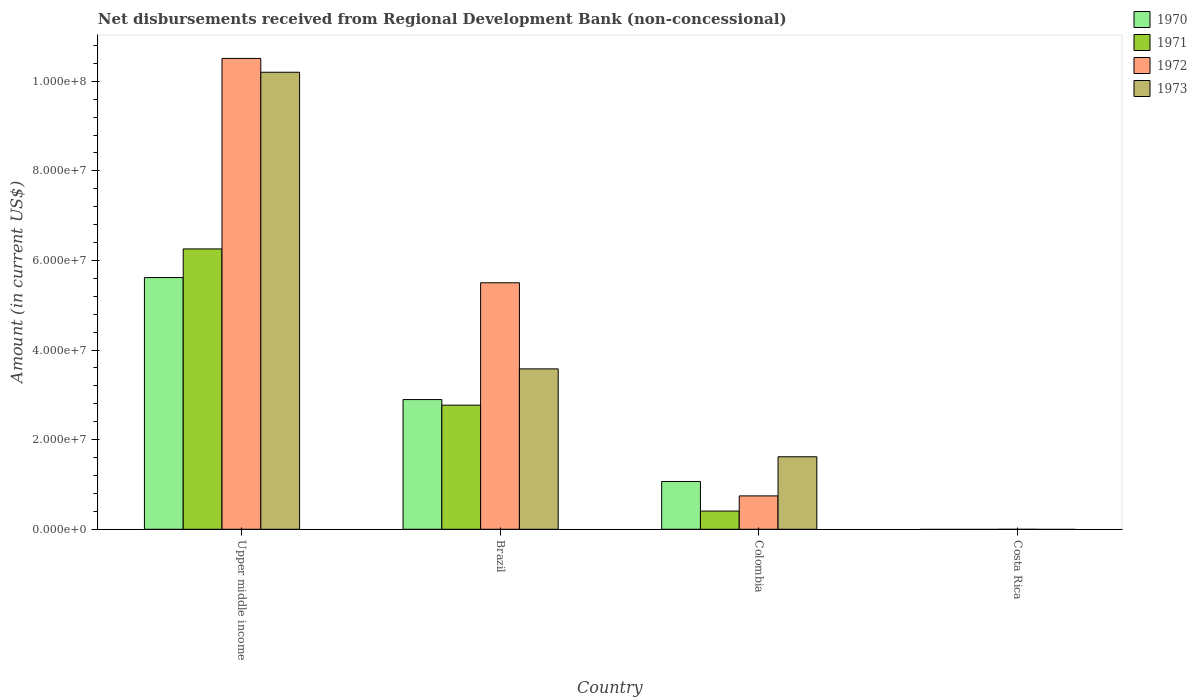Are the number of bars per tick equal to the number of legend labels?
Provide a short and direct response. No. What is the label of the 1st group of bars from the left?
Provide a short and direct response. Upper middle income. In how many cases, is the number of bars for a given country not equal to the number of legend labels?
Provide a succinct answer. 1. What is the amount of disbursements received from Regional Development Bank in 1970 in Colombia?
Offer a terse response. 1.07e+07. Across all countries, what is the maximum amount of disbursements received from Regional Development Bank in 1973?
Ensure brevity in your answer.  1.02e+08. In which country was the amount of disbursements received from Regional Development Bank in 1970 maximum?
Make the answer very short. Upper middle income. What is the total amount of disbursements received from Regional Development Bank in 1973 in the graph?
Your answer should be very brief. 1.54e+08. What is the difference between the amount of disbursements received from Regional Development Bank in 1973 in Brazil and that in Upper middle income?
Make the answer very short. -6.62e+07. What is the difference between the amount of disbursements received from Regional Development Bank in 1970 in Colombia and the amount of disbursements received from Regional Development Bank in 1972 in Costa Rica?
Keep it short and to the point. 1.07e+07. What is the average amount of disbursements received from Regional Development Bank in 1970 per country?
Provide a short and direct response. 2.40e+07. What is the difference between the amount of disbursements received from Regional Development Bank of/in 1972 and amount of disbursements received from Regional Development Bank of/in 1971 in Colombia?
Offer a terse response. 3.39e+06. What is the ratio of the amount of disbursements received from Regional Development Bank in 1971 in Brazil to that in Upper middle income?
Ensure brevity in your answer.  0.44. Is the amount of disbursements received from Regional Development Bank in 1971 in Brazil less than that in Colombia?
Your response must be concise. No. What is the difference between the highest and the second highest amount of disbursements received from Regional Development Bank in 1972?
Make the answer very short. 9.76e+07. What is the difference between the highest and the lowest amount of disbursements received from Regional Development Bank in 1970?
Your answer should be very brief. 5.62e+07. In how many countries, is the amount of disbursements received from Regional Development Bank in 1973 greater than the average amount of disbursements received from Regional Development Bank in 1973 taken over all countries?
Provide a short and direct response. 1. Is the sum of the amount of disbursements received from Regional Development Bank in 1972 in Brazil and Upper middle income greater than the maximum amount of disbursements received from Regional Development Bank in 1971 across all countries?
Your answer should be very brief. Yes. Is it the case that in every country, the sum of the amount of disbursements received from Regional Development Bank in 1972 and amount of disbursements received from Regional Development Bank in 1971 is greater than the sum of amount of disbursements received from Regional Development Bank in 1970 and amount of disbursements received from Regional Development Bank in 1973?
Ensure brevity in your answer.  No. How many countries are there in the graph?
Make the answer very short. 4. What is the difference between two consecutive major ticks on the Y-axis?
Keep it short and to the point. 2.00e+07. Does the graph contain any zero values?
Ensure brevity in your answer.  Yes. Does the graph contain grids?
Give a very brief answer. No. Where does the legend appear in the graph?
Offer a terse response. Top right. What is the title of the graph?
Ensure brevity in your answer.  Net disbursements received from Regional Development Bank (non-concessional). Does "2009" appear as one of the legend labels in the graph?
Your answer should be very brief. No. What is the label or title of the Y-axis?
Provide a succinct answer. Amount (in current US$). What is the Amount (in current US$) in 1970 in Upper middle income?
Provide a short and direct response. 5.62e+07. What is the Amount (in current US$) in 1971 in Upper middle income?
Your answer should be very brief. 6.26e+07. What is the Amount (in current US$) in 1972 in Upper middle income?
Ensure brevity in your answer.  1.05e+08. What is the Amount (in current US$) in 1973 in Upper middle income?
Your answer should be compact. 1.02e+08. What is the Amount (in current US$) of 1970 in Brazil?
Make the answer very short. 2.90e+07. What is the Amount (in current US$) in 1971 in Brazil?
Provide a short and direct response. 2.77e+07. What is the Amount (in current US$) of 1972 in Brazil?
Your answer should be compact. 5.50e+07. What is the Amount (in current US$) of 1973 in Brazil?
Provide a succinct answer. 3.58e+07. What is the Amount (in current US$) of 1970 in Colombia?
Ensure brevity in your answer.  1.07e+07. What is the Amount (in current US$) of 1971 in Colombia?
Your answer should be compact. 4.06e+06. What is the Amount (in current US$) of 1972 in Colombia?
Give a very brief answer. 7.45e+06. What is the Amount (in current US$) in 1973 in Colombia?
Provide a succinct answer. 1.62e+07. What is the Amount (in current US$) of 1971 in Costa Rica?
Give a very brief answer. 0. What is the Amount (in current US$) of 1973 in Costa Rica?
Provide a short and direct response. 0. Across all countries, what is the maximum Amount (in current US$) in 1970?
Keep it short and to the point. 5.62e+07. Across all countries, what is the maximum Amount (in current US$) of 1971?
Your answer should be very brief. 6.26e+07. Across all countries, what is the maximum Amount (in current US$) in 1972?
Your answer should be compact. 1.05e+08. Across all countries, what is the maximum Amount (in current US$) in 1973?
Your response must be concise. 1.02e+08. Across all countries, what is the minimum Amount (in current US$) of 1970?
Keep it short and to the point. 0. Across all countries, what is the minimum Amount (in current US$) of 1971?
Give a very brief answer. 0. Across all countries, what is the minimum Amount (in current US$) in 1972?
Offer a terse response. 0. Across all countries, what is the minimum Amount (in current US$) in 1973?
Offer a terse response. 0. What is the total Amount (in current US$) of 1970 in the graph?
Give a very brief answer. 9.58e+07. What is the total Amount (in current US$) in 1971 in the graph?
Provide a succinct answer. 9.43e+07. What is the total Amount (in current US$) of 1972 in the graph?
Offer a very short reply. 1.68e+08. What is the total Amount (in current US$) of 1973 in the graph?
Make the answer very short. 1.54e+08. What is the difference between the Amount (in current US$) in 1970 in Upper middle income and that in Brazil?
Your answer should be compact. 2.72e+07. What is the difference between the Amount (in current US$) in 1971 in Upper middle income and that in Brazil?
Keep it short and to the point. 3.49e+07. What is the difference between the Amount (in current US$) in 1972 in Upper middle income and that in Brazil?
Make the answer very short. 5.01e+07. What is the difference between the Amount (in current US$) of 1973 in Upper middle income and that in Brazil?
Your answer should be compact. 6.62e+07. What is the difference between the Amount (in current US$) in 1970 in Upper middle income and that in Colombia?
Your answer should be very brief. 4.55e+07. What is the difference between the Amount (in current US$) in 1971 in Upper middle income and that in Colombia?
Your response must be concise. 5.85e+07. What is the difference between the Amount (in current US$) in 1972 in Upper middle income and that in Colombia?
Make the answer very short. 9.76e+07. What is the difference between the Amount (in current US$) in 1973 in Upper middle income and that in Colombia?
Your answer should be compact. 8.58e+07. What is the difference between the Amount (in current US$) of 1970 in Brazil and that in Colombia?
Make the answer very short. 1.83e+07. What is the difference between the Amount (in current US$) in 1971 in Brazil and that in Colombia?
Make the answer very short. 2.36e+07. What is the difference between the Amount (in current US$) of 1972 in Brazil and that in Colombia?
Your response must be concise. 4.76e+07. What is the difference between the Amount (in current US$) of 1973 in Brazil and that in Colombia?
Offer a very short reply. 1.96e+07. What is the difference between the Amount (in current US$) of 1970 in Upper middle income and the Amount (in current US$) of 1971 in Brazil?
Offer a very short reply. 2.85e+07. What is the difference between the Amount (in current US$) in 1970 in Upper middle income and the Amount (in current US$) in 1972 in Brazil?
Your response must be concise. 1.16e+06. What is the difference between the Amount (in current US$) in 1970 in Upper middle income and the Amount (in current US$) in 1973 in Brazil?
Your response must be concise. 2.04e+07. What is the difference between the Amount (in current US$) in 1971 in Upper middle income and the Amount (in current US$) in 1972 in Brazil?
Your answer should be compact. 7.55e+06. What is the difference between the Amount (in current US$) in 1971 in Upper middle income and the Amount (in current US$) in 1973 in Brazil?
Keep it short and to the point. 2.68e+07. What is the difference between the Amount (in current US$) in 1972 in Upper middle income and the Amount (in current US$) in 1973 in Brazil?
Provide a short and direct response. 6.93e+07. What is the difference between the Amount (in current US$) of 1970 in Upper middle income and the Amount (in current US$) of 1971 in Colombia?
Provide a short and direct response. 5.21e+07. What is the difference between the Amount (in current US$) in 1970 in Upper middle income and the Amount (in current US$) in 1972 in Colombia?
Ensure brevity in your answer.  4.87e+07. What is the difference between the Amount (in current US$) of 1970 in Upper middle income and the Amount (in current US$) of 1973 in Colombia?
Your answer should be compact. 4.00e+07. What is the difference between the Amount (in current US$) of 1971 in Upper middle income and the Amount (in current US$) of 1972 in Colombia?
Provide a short and direct response. 5.51e+07. What is the difference between the Amount (in current US$) in 1971 in Upper middle income and the Amount (in current US$) in 1973 in Colombia?
Your answer should be compact. 4.64e+07. What is the difference between the Amount (in current US$) of 1972 in Upper middle income and the Amount (in current US$) of 1973 in Colombia?
Your response must be concise. 8.89e+07. What is the difference between the Amount (in current US$) of 1970 in Brazil and the Amount (in current US$) of 1971 in Colombia?
Offer a very short reply. 2.49e+07. What is the difference between the Amount (in current US$) of 1970 in Brazil and the Amount (in current US$) of 1972 in Colombia?
Provide a short and direct response. 2.15e+07. What is the difference between the Amount (in current US$) in 1970 in Brazil and the Amount (in current US$) in 1973 in Colombia?
Your answer should be compact. 1.28e+07. What is the difference between the Amount (in current US$) of 1971 in Brazil and the Amount (in current US$) of 1972 in Colombia?
Ensure brevity in your answer.  2.03e+07. What is the difference between the Amount (in current US$) of 1971 in Brazil and the Amount (in current US$) of 1973 in Colombia?
Offer a terse response. 1.15e+07. What is the difference between the Amount (in current US$) of 1972 in Brazil and the Amount (in current US$) of 1973 in Colombia?
Provide a short and direct response. 3.88e+07. What is the average Amount (in current US$) of 1970 per country?
Your response must be concise. 2.40e+07. What is the average Amount (in current US$) in 1971 per country?
Offer a terse response. 2.36e+07. What is the average Amount (in current US$) in 1972 per country?
Provide a succinct answer. 4.19e+07. What is the average Amount (in current US$) of 1973 per country?
Ensure brevity in your answer.  3.85e+07. What is the difference between the Amount (in current US$) of 1970 and Amount (in current US$) of 1971 in Upper middle income?
Your answer should be very brief. -6.39e+06. What is the difference between the Amount (in current US$) of 1970 and Amount (in current US$) of 1972 in Upper middle income?
Your answer should be very brief. -4.89e+07. What is the difference between the Amount (in current US$) of 1970 and Amount (in current US$) of 1973 in Upper middle income?
Provide a succinct answer. -4.58e+07. What is the difference between the Amount (in current US$) in 1971 and Amount (in current US$) in 1972 in Upper middle income?
Ensure brevity in your answer.  -4.25e+07. What is the difference between the Amount (in current US$) in 1971 and Amount (in current US$) in 1973 in Upper middle income?
Ensure brevity in your answer.  -3.94e+07. What is the difference between the Amount (in current US$) of 1972 and Amount (in current US$) of 1973 in Upper middle income?
Provide a succinct answer. 3.08e+06. What is the difference between the Amount (in current US$) in 1970 and Amount (in current US$) in 1971 in Brazil?
Provide a short and direct response. 1.25e+06. What is the difference between the Amount (in current US$) in 1970 and Amount (in current US$) in 1972 in Brazil?
Keep it short and to the point. -2.61e+07. What is the difference between the Amount (in current US$) in 1970 and Amount (in current US$) in 1973 in Brazil?
Provide a short and direct response. -6.85e+06. What is the difference between the Amount (in current US$) in 1971 and Amount (in current US$) in 1972 in Brazil?
Ensure brevity in your answer.  -2.73e+07. What is the difference between the Amount (in current US$) in 1971 and Amount (in current US$) in 1973 in Brazil?
Give a very brief answer. -8.10e+06. What is the difference between the Amount (in current US$) of 1972 and Amount (in current US$) of 1973 in Brazil?
Your answer should be very brief. 1.92e+07. What is the difference between the Amount (in current US$) in 1970 and Amount (in current US$) in 1971 in Colombia?
Make the answer very short. 6.61e+06. What is the difference between the Amount (in current US$) of 1970 and Amount (in current US$) of 1972 in Colombia?
Offer a very short reply. 3.22e+06. What is the difference between the Amount (in current US$) in 1970 and Amount (in current US$) in 1973 in Colombia?
Your answer should be very brief. -5.51e+06. What is the difference between the Amount (in current US$) in 1971 and Amount (in current US$) in 1972 in Colombia?
Provide a succinct answer. -3.39e+06. What is the difference between the Amount (in current US$) in 1971 and Amount (in current US$) in 1973 in Colombia?
Give a very brief answer. -1.21e+07. What is the difference between the Amount (in current US$) of 1972 and Amount (in current US$) of 1973 in Colombia?
Your answer should be very brief. -8.73e+06. What is the ratio of the Amount (in current US$) in 1970 in Upper middle income to that in Brazil?
Give a very brief answer. 1.94. What is the ratio of the Amount (in current US$) in 1971 in Upper middle income to that in Brazil?
Provide a succinct answer. 2.26. What is the ratio of the Amount (in current US$) in 1972 in Upper middle income to that in Brazil?
Keep it short and to the point. 1.91. What is the ratio of the Amount (in current US$) in 1973 in Upper middle income to that in Brazil?
Offer a terse response. 2.85. What is the ratio of the Amount (in current US$) in 1970 in Upper middle income to that in Colombia?
Keep it short and to the point. 5.27. What is the ratio of the Amount (in current US$) of 1971 in Upper middle income to that in Colombia?
Your answer should be very brief. 15.4. What is the ratio of the Amount (in current US$) of 1972 in Upper middle income to that in Colombia?
Your answer should be compact. 14.11. What is the ratio of the Amount (in current US$) in 1973 in Upper middle income to that in Colombia?
Offer a terse response. 6.3. What is the ratio of the Amount (in current US$) of 1970 in Brazil to that in Colombia?
Your response must be concise. 2.71. What is the ratio of the Amount (in current US$) in 1971 in Brazil to that in Colombia?
Provide a succinct answer. 6.82. What is the ratio of the Amount (in current US$) of 1972 in Brazil to that in Colombia?
Your response must be concise. 7.39. What is the ratio of the Amount (in current US$) in 1973 in Brazil to that in Colombia?
Make the answer very short. 2.21. What is the difference between the highest and the second highest Amount (in current US$) of 1970?
Make the answer very short. 2.72e+07. What is the difference between the highest and the second highest Amount (in current US$) in 1971?
Keep it short and to the point. 3.49e+07. What is the difference between the highest and the second highest Amount (in current US$) of 1972?
Keep it short and to the point. 5.01e+07. What is the difference between the highest and the second highest Amount (in current US$) of 1973?
Provide a succinct answer. 6.62e+07. What is the difference between the highest and the lowest Amount (in current US$) of 1970?
Your response must be concise. 5.62e+07. What is the difference between the highest and the lowest Amount (in current US$) of 1971?
Ensure brevity in your answer.  6.26e+07. What is the difference between the highest and the lowest Amount (in current US$) in 1972?
Provide a short and direct response. 1.05e+08. What is the difference between the highest and the lowest Amount (in current US$) of 1973?
Your response must be concise. 1.02e+08. 